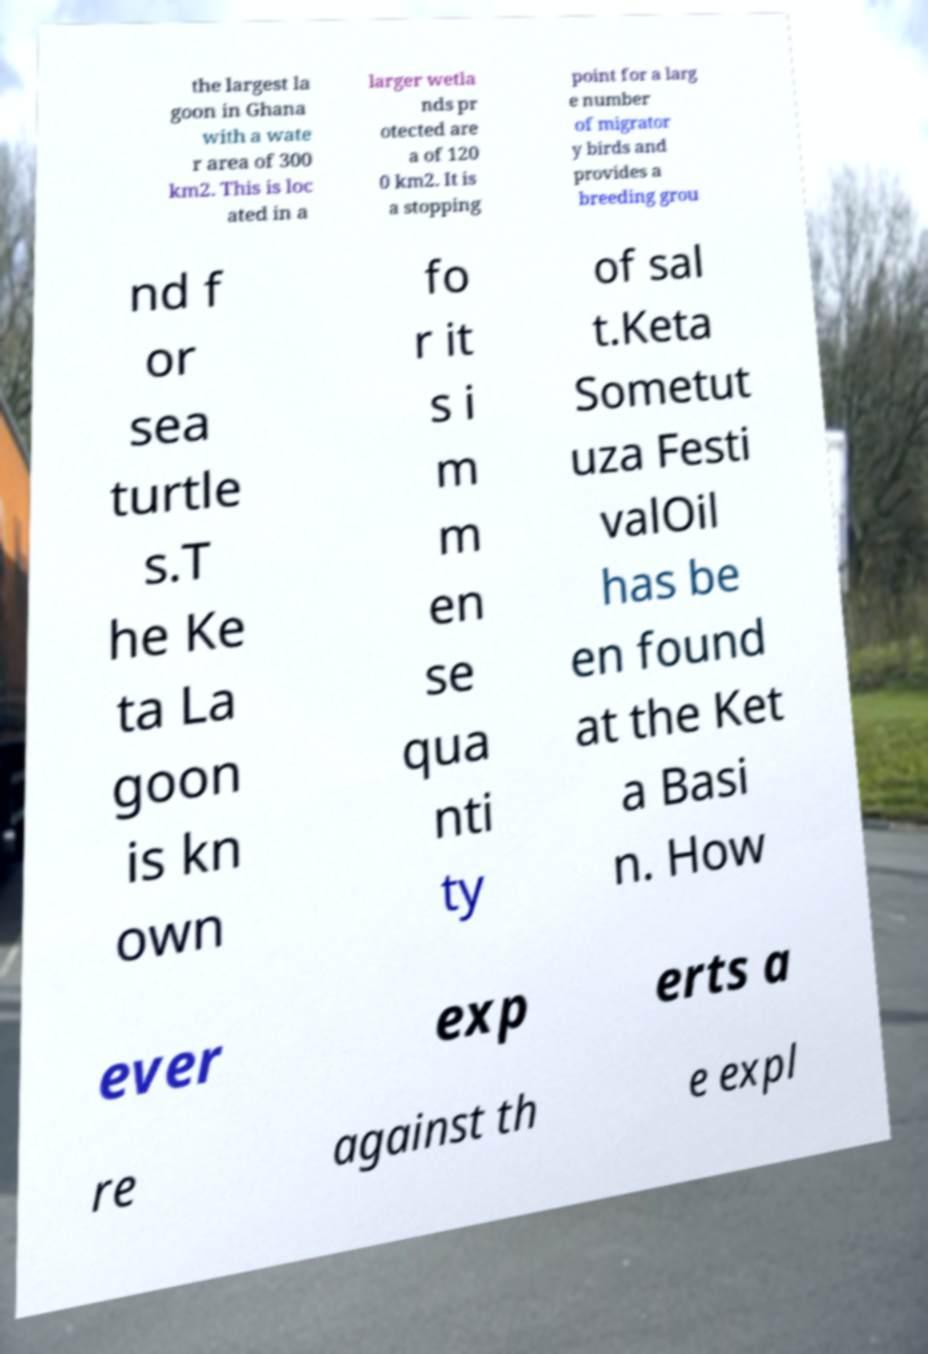Could you assist in decoding the text presented in this image and type it out clearly? the largest la goon in Ghana with a wate r area of 300 km2. This is loc ated in a larger wetla nds pr otected are a of 120 0 km2. It is a stopping point for a larg e number of migrator y birds and provides a breeding grou nd f or sea turtle s.T he Ke ta La goon is kn own fo r it s i m m en se qua nti ty of sal t.Keta Sometut uza Festi valOil has be en found at the Ket a Basi n. How ever exp erts a re against th e expl 